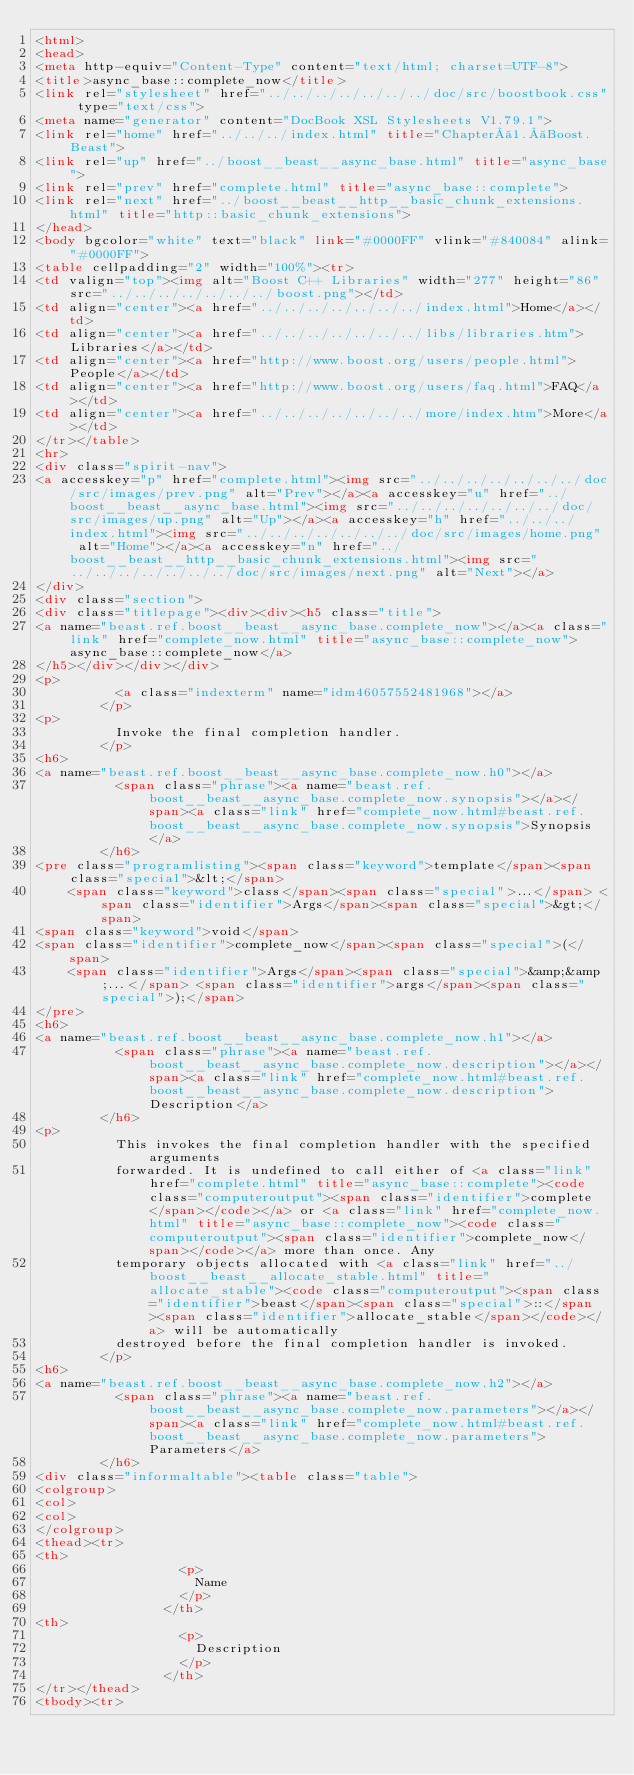<code> <loc_0><loc_0><loc_500><loc_500><_HTML_><html>
<head>
<meta http-equiv="Content-Type" content="text/html; charset=UTF-8">
<title>async_base::complete_now</title>
<link rel="stylesheet" href="../../../../../../../doc/src/boostbook.css" type="text/css">
<meta name="generator" content="DocBook XSL Stylesheets V1.79.1">
<link rel="home" href="../../../index.html" title="Chapter 1. Boost.Beast">
<link rel="up" href="../boost__beast__async_base.html" title="async_base">
<link rel="prev" href="complete.html" title="async_base::complete">
<link rel="next" href="../boost__beast__http__basic_chunk_extensions.html" title="http::basic_chunk_extensions">
</head>
<body bgcolor="white" text="black" link="#0000FF" vlink="#840084" alink="#0000FF">
<table cellpadding="2" width="100%"><tr>
<td valign="top"><img alt="Boost C++ Libraries" width="277" height="86" src="../../../../../../../boost.png"></td>
<td align="center"><a href="../../../../../../../index.html">Home</a></td>
<td align="center"><a href="../../../../../../../libs/libraries.htm">Libraries</a></td>
<td align="center"><a href="http://www.boost.org/users/people.html">People</a></td>
<td align="center"><a href="http://www.boost.org/users/faq.html">FAQ</a></td>
<td align="center"><a href="../../../../../../../more/index.htm">More</a></td>
</tr></table>
<hr>
<div class="spirit-nav">
<a accesskey="p" href="complete.html"><img src="../../../../../../../doc/src/images/prev.png" alt="Prev"></a><a accesskey="u" href="../boost__beast__async_base.html"><img src="../../../../../../../doc/src/images/up.png" alt="Up"></a><a accesskey="h" href="../../../index.html"><img src="../../../../../../../doc/src/images/home.png" alt="Home"></a><a accesskey="n" href="../boost__beast__http__basic_chunk_extensions.html"><img src="../../../../../../../doc/src/images/next.png" alt="Next"></a>
</div>
<div class="section">
<div class="titlepage"><div><div><h5 class="title">
<a name="beast.ref.boost__beast__async_base.complete_now"></a><a class="link" href="complete_now.html" title="async_base::complete_now">async_base::complete_now</a>
</h5></div></div></div>
<p>
          <a class="indexterm" name="idm46057552481968"></a>
        </p>
<p>
          Invoke the final completion handler.
        </p>
<h6>
<a name="beast.ref.boost__beast__async_base.complete_now.h0"></a>
          <span class="phrase"><a name="beast.ref.boost__beast__async_base.complete_now.synopsis"></a></span><a class="link" href="complete_now.html#beast.ref.boost__beast__async_base.complete_now.synopsis">Synopsis</a>
        </h6>
<pre class="programlisting"><span class="keyword">template</span><span class="special">&lt;</span>
    <span class="keyword">class</span><span class="special">...</span> <span class="identifier">Args</span><span class="special">&gt;</span>
<span class="keyword">void</span>
<span class="identifier">complete_now</span><span class="special">(</span>
    <span class="identifier">Args</span><span class="special">&amp;&amp;...</span> <span class="identifier">args</span><span class="special">);</span>
</pre>
<h6>
<a name="beast.ref.boost__beast__async_base.complete_now.h1"></a>
          <span class="phrase"><a name="beast.ref.boost__beast__async_base.complete_now.description"></a></span><a class="link" href="complete_now.html#beast.ref.boost__beast__async_base.complete_now.description">Description</a>
        </h6>
<p>
          This invokes the final completion handler with the specified arguments
          forwarded. It is undefined to call either of <a class="link" href="complete.html" title="async_base::complete"><code class="computeroutput"><span class="identifier">complete</span></code></a> or <a class="link" href="complete_now.html" title="async_base::complete_now"><code class="computeroutput"><span class="identifier">complete_now</span></code></a> more than once. Any
          temporary objects allocated with <a class="link" href="../boost__beast__allocate_stable.html" title="allocate_stable"><code class="computeroutput"><span class="identifier">beast</span><span class="special">::</span><span class="identifier">allocate_stable</span></code></a> will be automatically
          destroyed before the final completion handler is invoked.
        </p>
<h6>
<a name="beast.ref.boost__beast__async_base.complete_now.h2"></a>
          <span class="phrase"><a name="beast.ref.boost__beast__async_base.complete_now.parameters"></a></span><a class="link" href="complete_now.html#beast.ref.boost__beast__async_base.complete_now.parameters">Parameters</a>
        </h6>
<div class="informaltable"><table class="table">
<colgroup>
<col>
<col>
</colgroup>
<thead><tr>
<th>
                  <p>
                    Name
                  </p>
                </th>
<th>
                  <p>
                    Description
                  </p>
                </th>
</tr></thead>
<tbody><tr></code> 